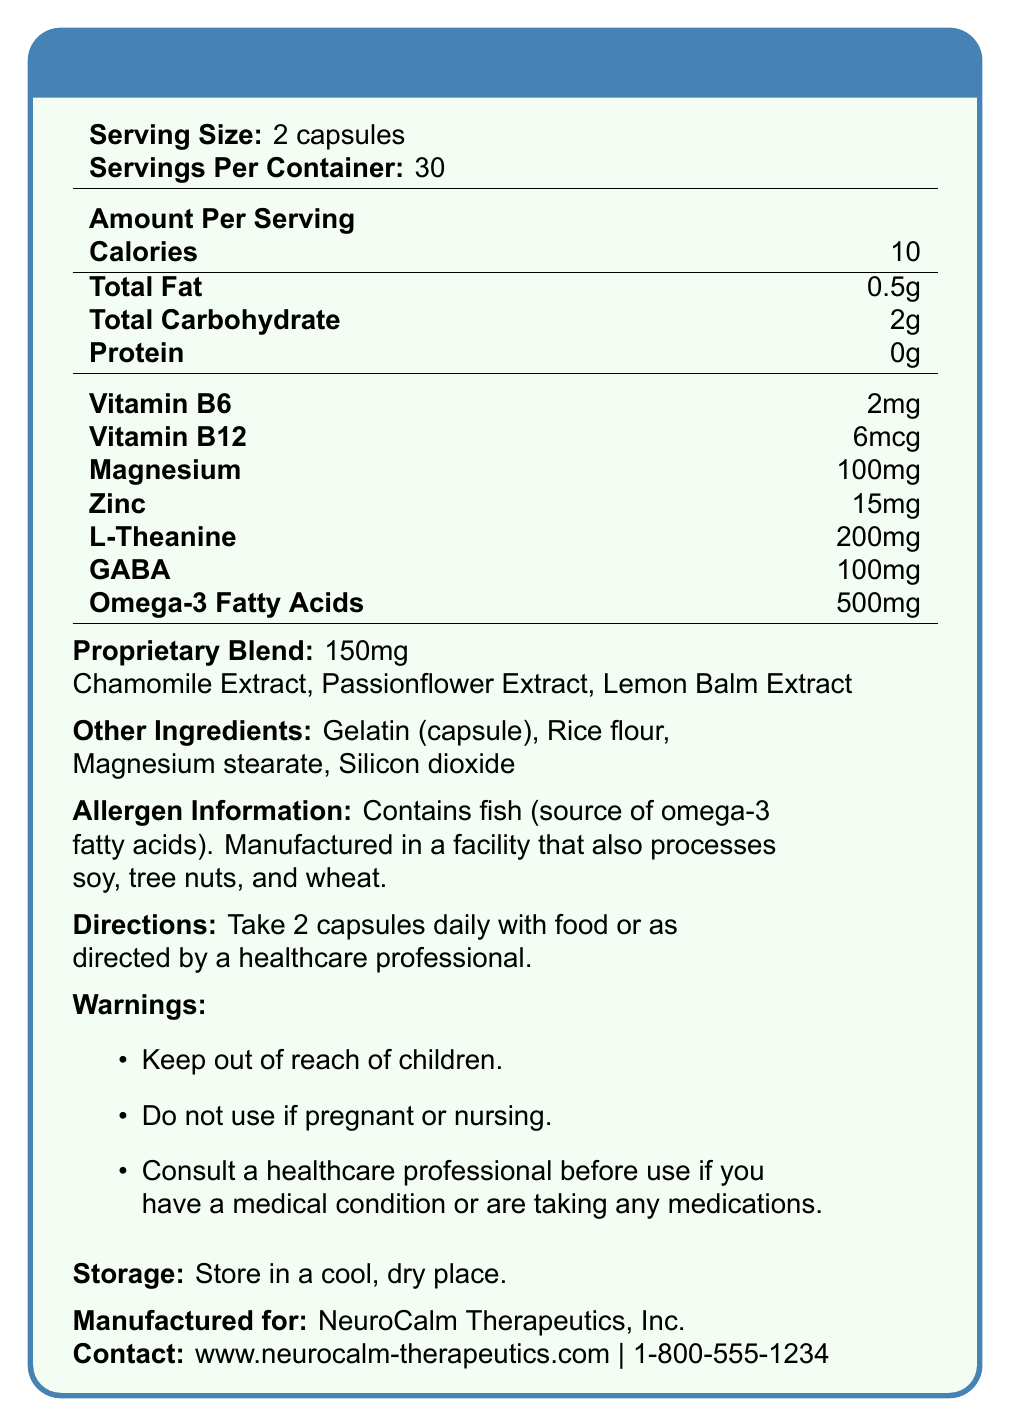what is the serving size? The document lists the serving size as "2 capsules" under the "Serving Size" section.
Answer: 2 capsules how many servings are there per container? The document states "Servings Per Container: 30".
Answer: 30 how many calories are in each serving? Under the "Amount Per Serving" section, it states the calories are 10 per serving.
Answer: 10 calories how much Vitamin B6 is provided per serving? The "Amount Per Serving" section lists Vitamin B6 content as 2mg.
Answer: 2mg what are the directions for taking this supplement? The "Directions" section clearly states the instructions.
Answer: Take 2 capsules daily with food or as directed by a healthcare professional. which ingredient in the proprietary blend is present? A. Magnesium B. Passionflower Extract C. Omega-3 Fatty Acids D. Gelatin (capsule) The proprietary blend includes Chamomile Extract, Passionflower Extract, and Lemon Balm Extract, as listed in the document.
Answer: B. Passionflower Extract how many capsules should be taken daily? A. 1 B. 2 C. 3 D. 4 The document states the serving size is 2 capsules, and the directions also confirm taking 2 capsules daily.
Answer: B. 2 does the supplement contain any allergens? The allergen information section mentions that the product contains fish as a source of omega-3 fatty acids.
Answer: Yes what is the total fat content per serving? The "Amount Per Serving" section lists Total Fat as 0.5g.
Answer: 0.5g summarize the main idea of the document. The document outlines the composition and usage information of SensoryBalance Plus, highlighting its catering to sensory processing disorders with essential nutrients and specific extracts, along with necessary warnings and allergen details.
Answer: The document provides detailed nutritional information for SensoryBalance Plus, a dietary supplement designed for individuals with sensory processing disorders. It includes serving size, caloric content, amounts of specific vitamins and minerals, a proprietary blend, other ingredients, allergen information, directions for use, warnings, and storage details. is the supplement recommended for pregnant women? The warnings section explicitly advises against use if pregnant or nursing.
Answer: No what is the magnesium content per serving? Under the "Amount Per Serving" section, magnesium content is listed as 100mg.
Answer: 100mg who is the manufacturer of the supplement? The manufacturer information at the bottom of the document lists "NeuroCalm Therapeutics, Inc.".
Answer: NeuroCalm Therapeutics, Inc. can someone with a nut allergy take this supplement safely? The document states it's manufactured in a facility that processes tree nuts, which suggests potential cross-contamination but doesn't provide a definitive answer about safety for people with nut allergies.
Answer: Not enough information what is the storage instruction for the supplement? The "Storage" section provides the instruction to store the supplement in a cool, dry place.
Answer: Store in a cool, dry place. 